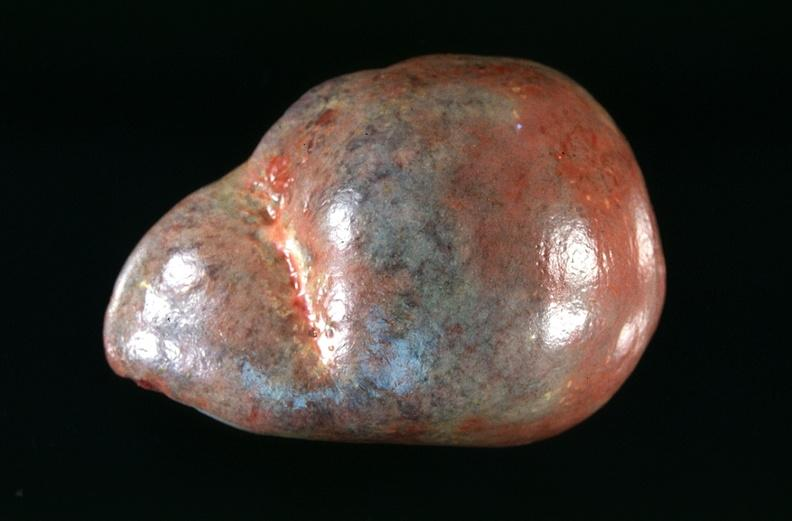s this present?
Answer the question using a single word or phrase. No 